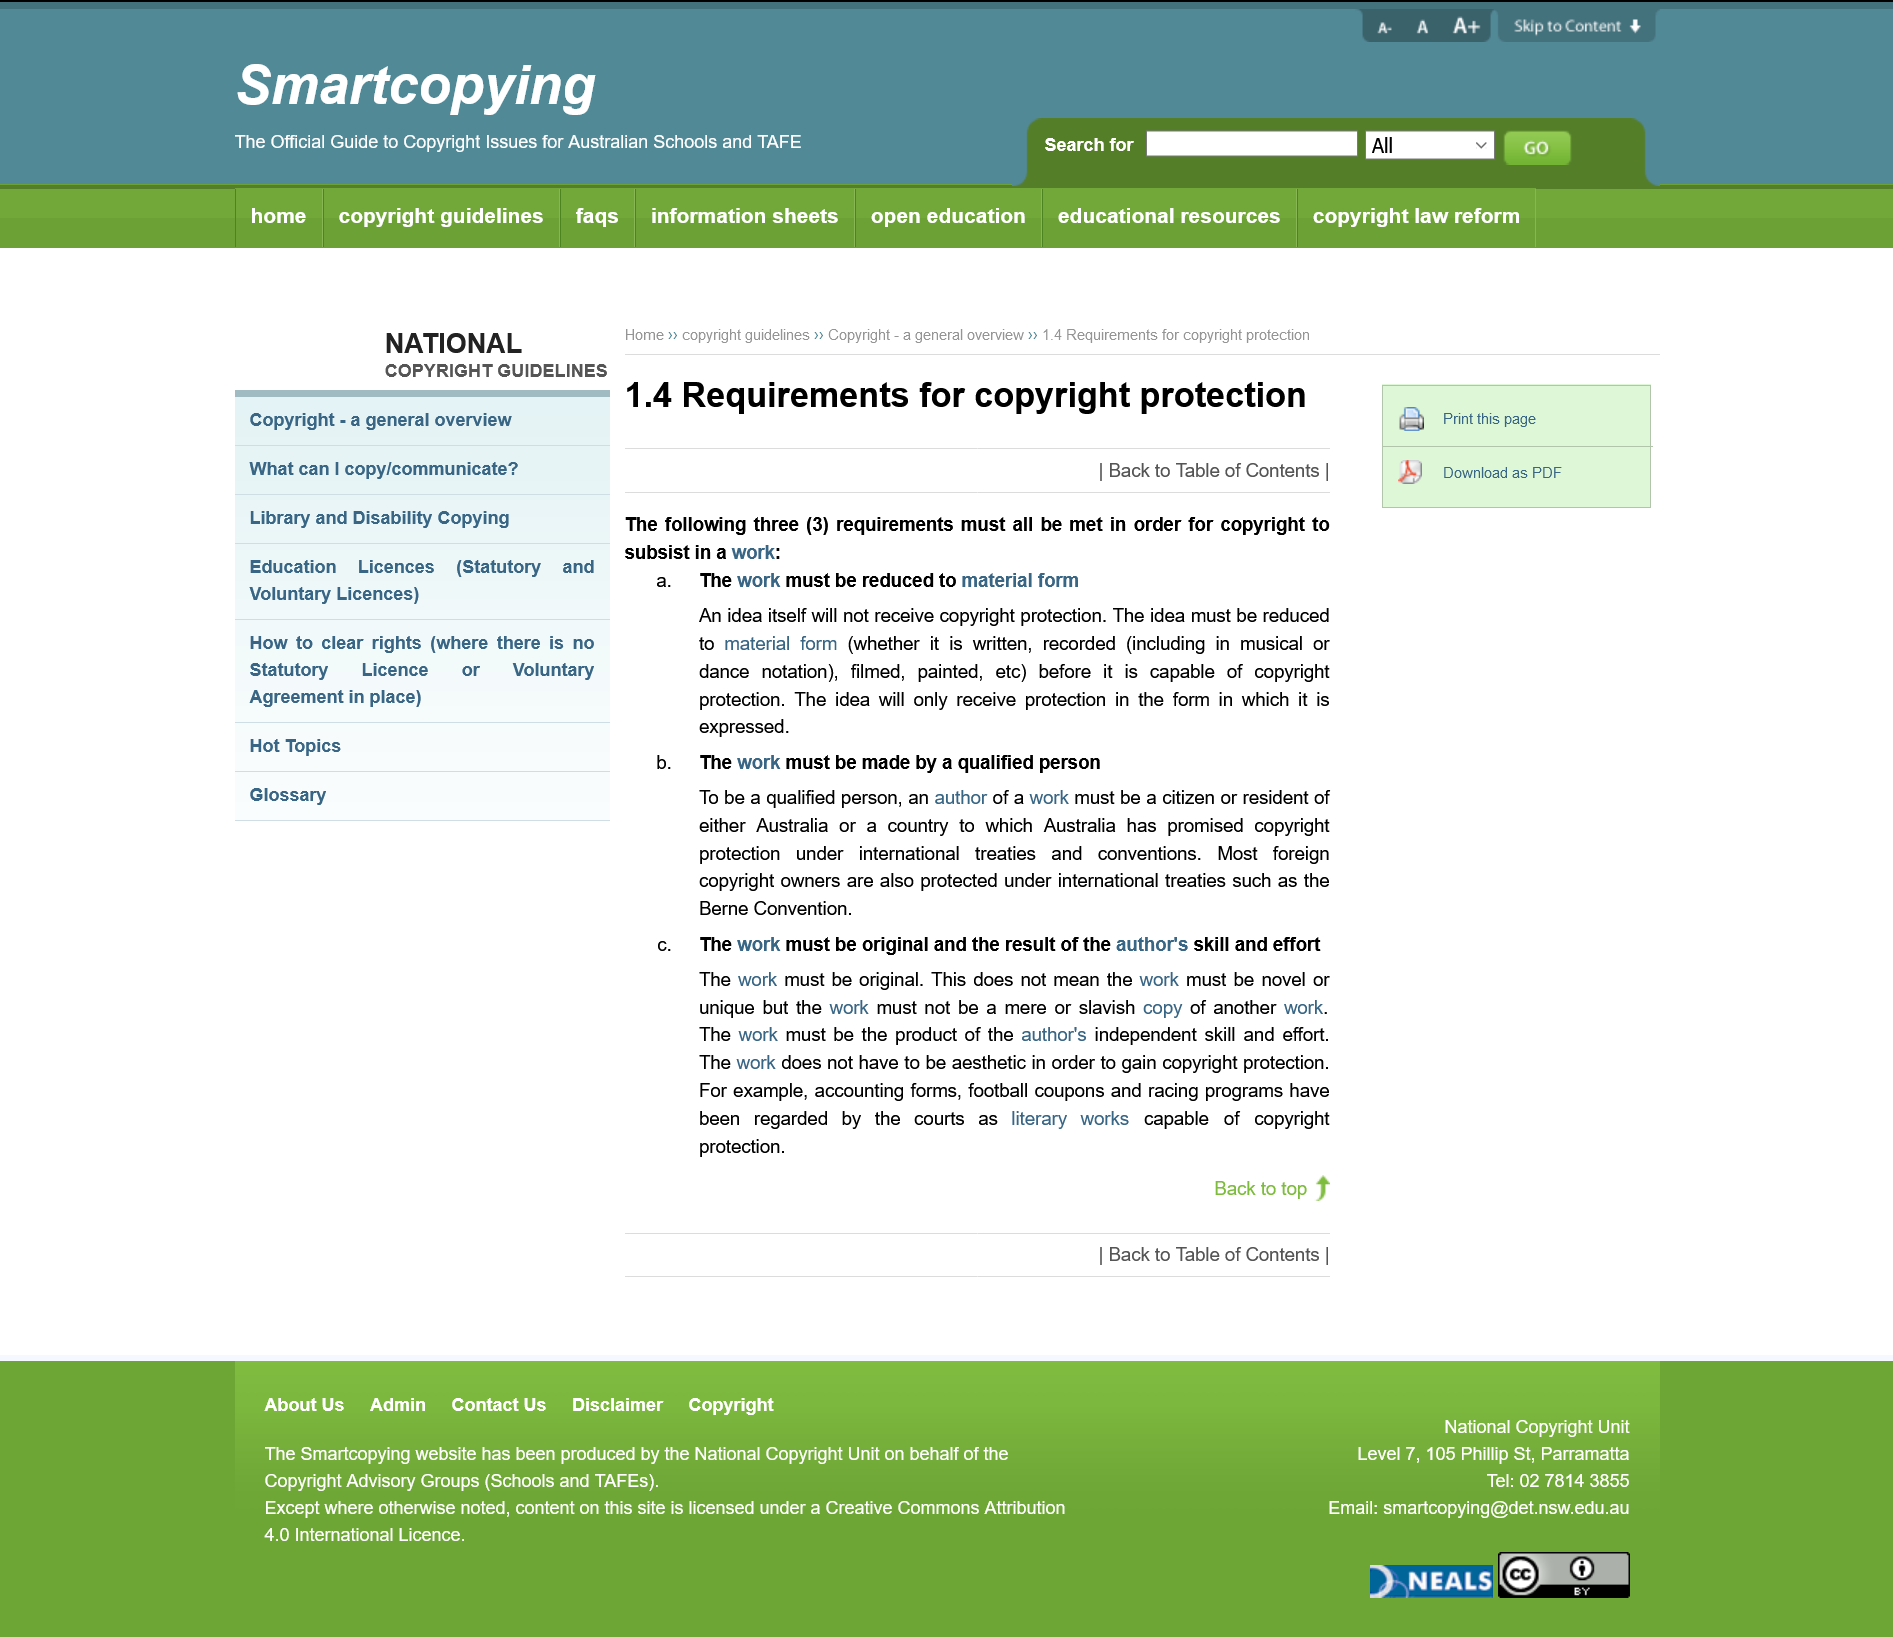Give some essential details in this illustration. To qualify for a copyright, the author of a work must be a citizen or resident of Australia, or a citizen or resident of one of the countries to which Australia has promised copyright protection, as stated in the previous sentence. To copyright a work, the following two requirements must be met: first, the work must be reduced to a material form, and second, it must be created by a qualified individual. It is not possible to copyright an idea. 